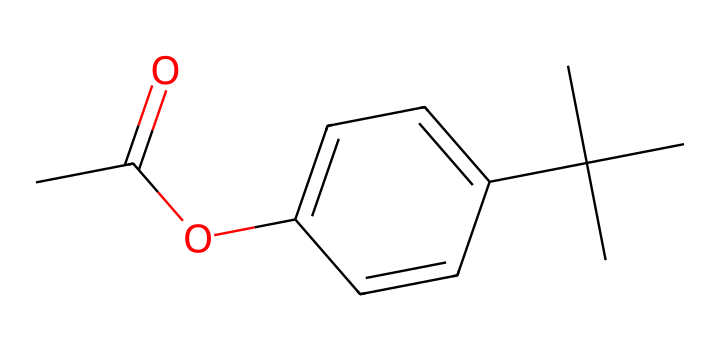what is the total number of carbon atoms in this chemical? By examining the SMILES representation, we can count all the 'C' characters that represent carbon atoms. In this case, there are a total of 15 carbon atoms in the structure.
Answer: 15 how many double bonds are present in this molecule? Looking at the SMILES notation, the part "C=O" and the "C=C" in the cyclohexene ring indicate that there are two double bonds within the structure.
Answer: 2 what type of chemical functional group is indicated by "OC" in the SMILES? The "OC" portion suggests the presence of an ester functional group, as it indicates an oxygen atom connected to the carbon of a carbonyl (C=O) and another carbon atom.
Answer: ester what is the primary feature of this compound that allows it to function as a preservative in cosmetics? The chemical has multiple hydrocarbon chains and oxygen atoms, contributing to its hydrophobic properties and ability to inhibit microbial growth, which is essential for a cosmetic preservative.
Answer: hydrophobic properties which part of the molecule is likely responsible for its long-lasting effect in makeup? The presence of bulky hydrocarbon groups (like the tert-butyl group) contributes to the stability and long-lasting properties of this cosmetic chemical, allowing it to adhere well to the skin.
Answer: bulky hydrocarbon groups 